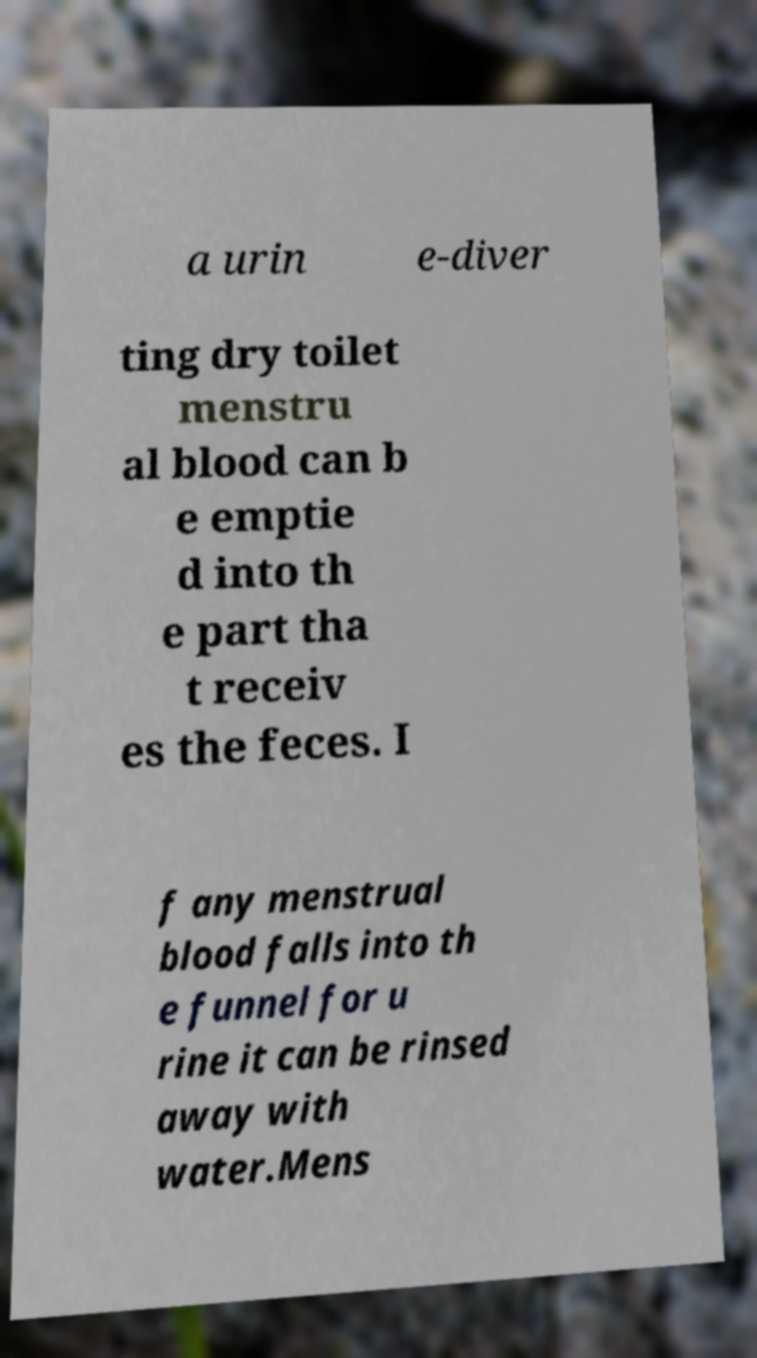Could you assist in decoding the text presented in this image and type it out clearly? a urin e-diver ting dry toilet menstru al blood can b e emptie d into th e part tha t receiv es the feces. I f any menstrual blood falls into th e funnel for u rine it can be rinsed away with water.Mens 